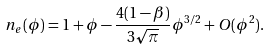<formula> <loc_0><loc_0><loc_500><loc_500>n _ { e } ( \phi ) = 1 + \phi - \frac { 4 ( 1 - \beta ) } { 3 \sqrt { \pi } } \phi ^ { 3 / 2 } + O ( \phi ^ { 2 } ) .</formula> 